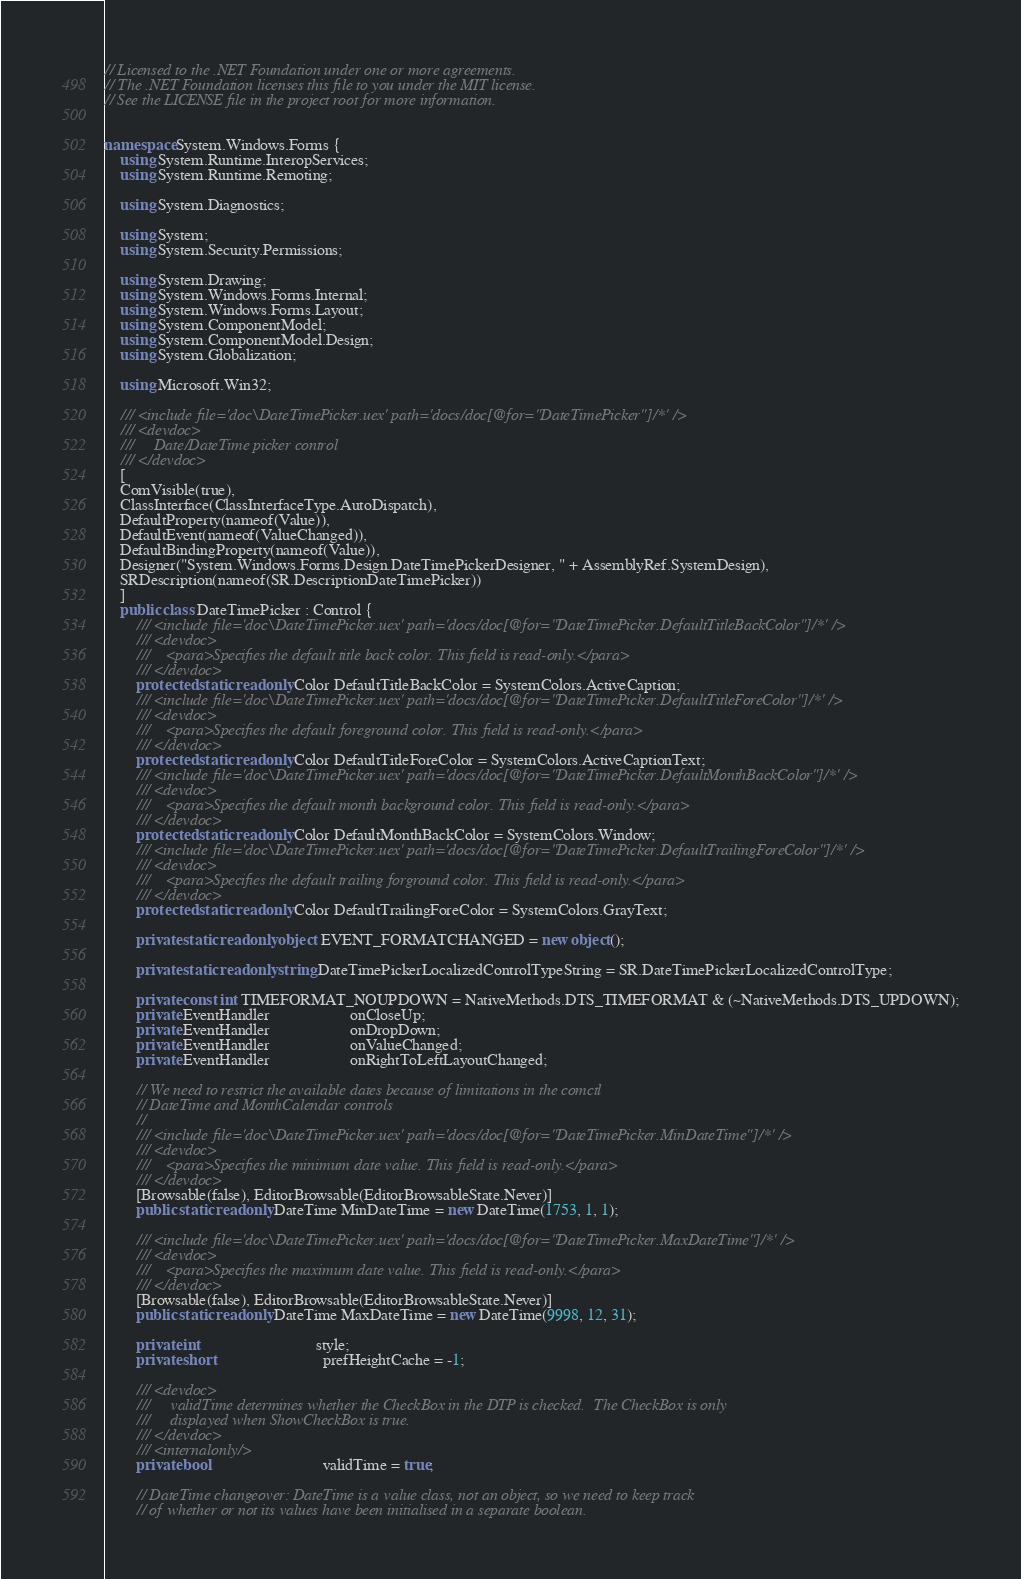Convert code to text. <code><loc_0><loc_0><loc_500><loc_500><_C#_>// Licensed to the .NET Foundation under one or more agreements.
// The .NET Foundation licenses this file to you under the MIT license.
// See the LICENSE file in the project root for more information.


namespace System.Windows.Forms {
    using System.Runtime.InteropServices;
    using System.Runtime.Remoting;

    using System.Diagnostics;

    using System;
    using System.Security.Permissions;

    using System.Drawing;
    using System.Windows.Forms.Internal;
    using System.Windows.Forms.Layout;
    using System.ComponentModel;
    using System.ComponentModel.Design;
    using System.Globalization;

    using Microsoft.Win32;

    /// <include file='doc\DateTimePicker.uex' path='docs/doc[@for="DateTimePicker"]/*' />
    /// <devdoc>
    ///     Date/DateTime picker control
    /// </devdoc>
    [
    ComVisible(true),
    ClassInterface(ClassInterfaceType.AutoDispatch),
    DefaultProperty(nameof(Value)),
    DefaultEvent(nameof(ValueChanged)),
    DefaultBindingProperty(nameof(Value)),
    Designer("System.Windows.Forms.Design.DateTimePickerDesigner, " + AssemblyRef.SystemDesign),
    SRDescription(nameof(SR.DescriptionDateTimePicker))
    ]
    public class DateTimePicker : Control {
        /// <include file='doc\DateTimePicker.uex' path='docs/doc[@for="DateTimePicker.DefaultTitleBackColor"]/*' />
        /// <devdoc>
        ///    <para>Specifies the default title back color. This field is read-only.</para>
        /// </devdoc>
        protected static readonly Color DefaultTitleBackColor = SystemColors.ActiveCaption;
        /// <include file='doc\DateTimePicker.uex' path='docs/doc[@for="DateTimePicker.DefaultTitleForeColor"]/*' />
        /// <devdoc>
        ///    <para>Specifies the default foreground color. This field is read-only.</para>
        /// </devdoc>
        protected static readonly Color DefaultTitleForeColor = SystemColors.ActiveCaptionText;
        /// <include file='doc\DateTimePicker.uex' path='docs/doc[@for="DateTimePicker.DefaultMonthBackColor"]/*' />
        /// <devdoc>
        ///    <para>Specifies the default month background color. This field is read-only.</para>
        /// </devdoc>
        protected static readonly Color DefaultMonthBackColor = SystemColors.Window;
        /// <include file='doc\DateTimePicker.uex' path='docs/doc[@for="DateTimePicker.DefaultTrailingForeColor"]/*' />
        /// <devdoc>
        ///    <para>Specifies the default trailing forground color. This field is read-only.</para>
        /// </devdoc>
        protected static readonly Color DefaultTrailingForeColor = SystemColors.GrayText;

        private static readonly object EVENT_FORMATCHANGED = new object();

        private static readonly string DateTimePickerLocalizedControlTypeString = SR.DateTimePickerLocalizedControlType;

        private const int TIMEFORMAT_NOUPDOWN = NativeMethods.DTS_TIMEFORMAT & (~NativeMethods.DTS_UPDOWN);
        private EventHandler                    onCloseUp;
        private EventHandler                    onDropDown;
        private EventHandler                    onValueChanged;
        private EventHandler                    onRightToLeftLayoutChanged;

        // We need to restrict the available dates because of limitations in the comctl
        // DateTime and MonthCalendar controls
        //
        /// <include file='doc\DateTimePicker.uex' path='docs/doc[@for="DateTimePicker.MinDateTime"]/*' />
        /// <devdoc>
        ///    <para>Specifies the minimum date value. This field is read-only.</para>
        /// </devdoc>
        [Browsable(false), EditorBrowsable(EditorBrowsableState.Never)]
        public static readonly DateTime MinDateTime = new DateTime(1753, 1, 1);

        /// <include file='doc\DateTimePicker.uex' path='docs/doc[@for="DateTimePicker.MaxDateTime"]/*' />
        /// <devdoc>
        ///    <para>Specifies the maximum date value. This field is read-only.</para>
        /// </devdoc>
        [Browsable(false), EditorBrowsable(EditorBrowsableState.Never)]
        public static readonly DateTime MaxDateTime = new DateTime(9998, 12, 31);

        private int                             style;
        private short                           prefHeightCache = -1;

        /// <devdoc>
        ///     validTime determines whether the CheckBox in the DTP is checked.  The CheckBox is only
        ///     displayed when ShowCheckBox is true.
        /// </devdoc>
        /// <internalonly/>
        private bool                            validTime = true;

        // DateTime changeover: DateTime is a value class, not an object, so we need to keep track
        // of whether or not its values have been initialised in a separate boolean.</code> 